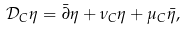Convert formula to latex. <formula><loc_0><loc_0><loc_500><loc_500>\mathcal { D } _ { C } \eta = \bar { \partial } \eta + \nu _ { C } \eta + \mu _ { C } \bar { \eta } ,</formula> 